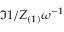<formula> <loc_0><loc_0><loc_500><loc_500>\Im { 1 / Z _ { ( 1 ) } } \omega ^ { - 1 }</formula> 